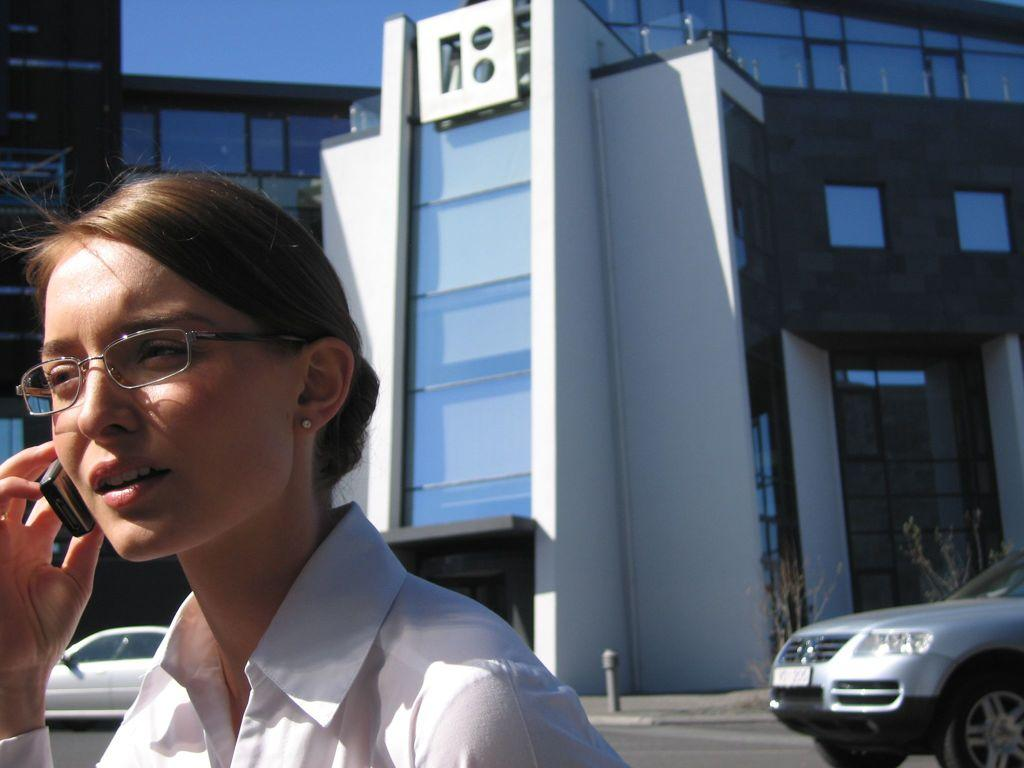Who is present in the image? There is a woman in the image. What is the woman wearing? The woman is wearing spectacles. What is the woman holding in the image? The woman is holding a mobile. What can be seen in the background of the image? There are cars and buildings in the background of the image. What shape is the page the woman is reading in the image? There is no page present in the image, as the woman is holding a mobile instead. 